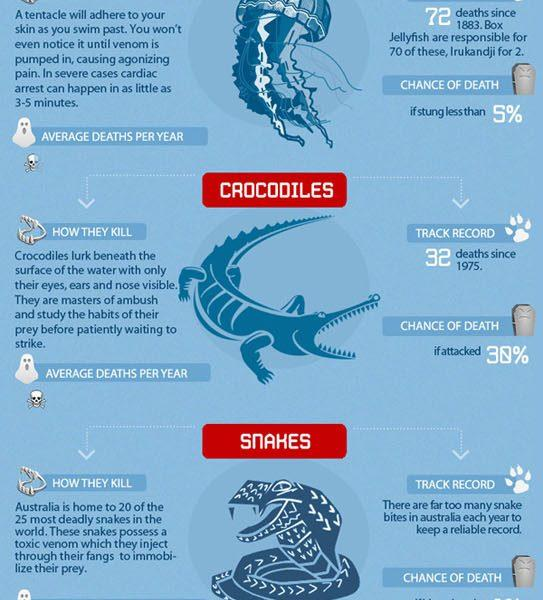Point out several critical features in this image. There are 3 creatures depicted in the images. According to reports, approximately 70 deaths have been attributed to encounters with Box Jellyfish. 